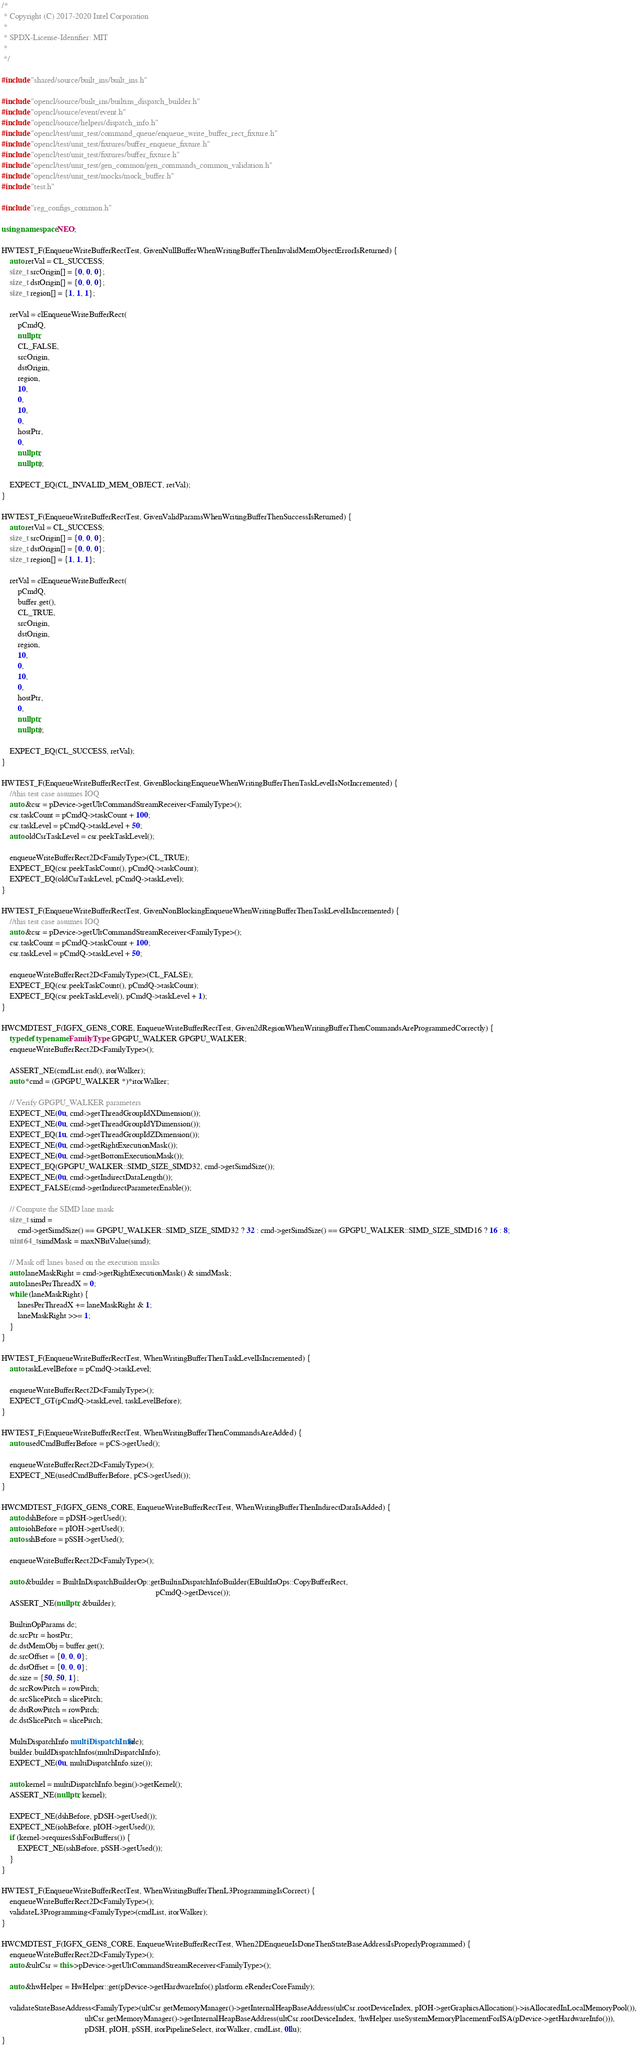Convert code to text. <code><loc_0><loc_0><loc_500><loc_500><_C++_>/*
 * Copyright (C) 2017-2020 Intel Corporation
 *
 * SPDX-License-Identifier: MIT
 *
 */

#include "shared/source/built_ins/built_ins.h"

#include "opencl/source/built_ins/builtins_dispatch_builder.h"
#include "opencl/source/event/event.h"
#include "opencl/source/helpers/dispatch_info.h"
#include "opencl/test/unit_test/command_queue/enqueue_write_buffer_rect_fixture.h"
#include "opencl/test/unit_test/fixtures/buffer_enqueue_fixture.h"
#include "opencl/test/unit_test/fixtures/buffer_fixture.h"
#include "opencl/test/unit_test/gen_common/gen_commands_common_validation.h"
#include "opencl/test/unit_test/mocks/mock_buffer.h"
#include "test.h"

#include "reg_configs_common.h"

using namespace NEO;

HWTEST_F(EnqueueWriteBufferRectTest, GivenNullBufferWhenWritingBufferThenInvalidMemObjectErrorIsReturned) {
    auto retVal = CL_SUCCESS;
    size_t srcOrigin[] = {0, 0, 0};
    size_t dstOrigin[] = {0, 0, 0};
    size_t region[] = {1, 1, 1};

    retVal = clEnqueueWriteBufferRect(
        pCmdQ,
        nullptr,
        CL_FALSE,
        srcOrigin,
        dstOrigin,
        region,
        10,
        0,
        10,
        0,
        hostPtr,
        0,
        nullptr,
        nullptr);

    EXPECT_EQ(CL_INVALID_MEM_OBJECT, retVal);
}

HWTEST_F(EnqueueWriteBufferRectTest, GivenValidParamsWhenWritingBufferThenSuccessIsReturned) {
    auto retVal = CL_SUCCESS;
    size_t srcOrigin[] = {0, 0, 0};
    size_t dstOrigin[] = {0, 0, 0};
    size_t region[] = {1, 1, 1};

    retVal = clEnqueueWriteBufferRect(
        pCmdQ,
        buffer.get(),
        CL_TRUE,
        srcOrigin,
        dstOrigin,
        region,
        10,
        0,
        10,
        0,
        hostPtr,
        0,
        nullptr,
        nullptr);

    EXPECT_EQ(CL_SUCCESS, retVal);
}

HWTEST_F(EnqueueWriteBufferRectTest, GivenBlockingEnqueueWhenWritingBufferThenTaskLevelIsNotIncremented) {
    //this test case assumes IOQ
    auto &csr = pDevice->getUltCommandStreamReceiver<FamilyType>();
    csr.taskCount = pCmdQ->taskCount + 100;
    csr.taskLevel = pCmdQ->taskLevel + 50;
    auto oldCsrTaskLevel = csr.peekTaskLevel();

    enqueueWriteBufferRect2D<FamilyType>(CL_TRUE);
    EXPECT_EQ(csr.peekTaskCount(), pCmdQ->taskCount);
    EXPECT_EQ(oldCsrTaskLevel, pCmdQ->taskLevel);
}

HWTEST_F(EnqueueWriteBufferRectTest, GivenNonBlockingEnqueueWhenWritingBufferThenTaskLevelIsIncremented) {
    //this test case assumes IOQ
    auto &csr = pDevice->getUltCommandStreamReceiver<FamilyType>();
    csr.taskCount = pCmdQ->taskCount + 100;
    csr.taskLevel = pCmdQ->taskLevel + 50;

    enqueueWriteBufferRect2D<FamilyType>(CL_FALSE);
    EXPECT_EQ(csr.peekTaskCount(), pCmdQ->taskCount);
    EXPECT_EQ(csr.peekTaskLevel(), pCmdQ->taskLevel + 1);
}

HWCMDTEST_F(IGFX_GEN8_CORE, EnqueueWriteBufferRectTest, Given2dRegionWhenWritingBufferThenCommandsAreProgrammedCorrectly) {
    typedef typename FamilyType::GPGPU_WALKER GPGPU_WALKER;
    enqueueWriteBufferRect2D<FamilyType>();

    ASSERT_NE(cmdList.end(), itorWalker);
    auto *cmd = (GPGPU_WALKER *)*itorWalker;

    // Verify GPGPU_WALKER parameters
    EXPECT_NE(0u, cmd->getThreadGroupIdXDimension());
    EXPECT_NE(0u, cmd->getThreadGroupIdYDimension());
    EXPECT_EQ(1u, cmd->getThreadGroupIdZDimension());
    EXPECT_NE(0u, cmd->getRightExecutionMask());
    EXPECT_NE(0u, cmd->getBottomExecutionMask());
    EXPECT_EQ(GPGPU_WALKER::SIMD_SIZE_SIMD32, cmd->getSimdSize());
    EXPECT_NE(0u, cmd->getIndirectDataLength());
    EXPECT_FALSE(cmd->getIndirectParameterEnable());

    // Compute the SIMD lane mask
    size_t simd =
        cmd->getSimdSize() == GPGPU_WALKER::SIMD_SIZE_SIMD32 ? 32 : cmd->getSimdSize() == GPGPU_WALKER::SIMD_SIZE_SIMD16 ? 16 : 8;
    uint64_t simdMask = maxNBitValue(simd);

    // Mask off lanes based on the execution masks
    auto laneMaskRight = cmd->getRightExecutionMask() & simdMask;
    auto lanesPerThreadX = 0;
    while (laneMaskRight) {
        lanesPerThreadX += laneMaskRight & 1;
        laneMaskRight >>= 1;
    }
}

HWTEST_F(EnqueueWriteBufferRectTest, WhenWritingBufferThenTaskLevelIsIncremented) {
    auto taskLevelBefore = pCmdQ->taskLevel;

    enqueueWriteBufferRect2D<FamilyType>();
    EXPECT_GT(pCmdQ->taskLevel, taskLevelBefore);
}

HWTEST_F(EnqueueWriteBufferRectTest, WhenWritingBufferThenCommandsAreAdded) {
    auto usedCmdBufferBefore = pCS->getUsed();

    enqueueWriteBufferRect2D<FamilyType>();
    EXPECT_NE(usedCmdBufferBefore, pCS->getUsed());
}

HWCMDTEST_F(IGFX_GEN8_CORE, EnqueueWriteBufferRectTest, WhenWritingBufferThenIndirectDataIsAdded) {
    auto dshBefore = pDSH->getUsed();
    auto iohBefore = pIOH->getUsed();
    auto sshBefore = pSSH->getUsed();

    enqueueWriteBufferRect2D<FamilyType>();

    auto &builder = BuiltInDispatchBuilderOp::getBuiltinDispatchInfoBuilder(EBuiltInOps::CopyBufferRect,
                                                                            pCmdQ->getDevice());
    ASSERT_NE(nullptr, &builder);

    BuiltinOpParams dc;
    dc.srcPtr = hostPtr;
    dc.dstMemObj = buffer.get();
    dc.srcOffset = {0, 0, 0};
    dc.dstOffset = {0, 0, 0};
    dc.size = {50, 50, 1};
    dc.srcRowPitch = rowPitch;
    dc.srcSlicePitch = slicePitch;
    dc.dstRowPitch = rowPitch;
    dc.dstSlicePitch = slicePitch;

    MultiDispatchInfo multiDispatchInfo(dc);
    builder.buildDispatchInfos(multiDispatchInfo);
    EXPECT_NE(0u, multiDispatchInfo.size());

    auto kernel = multiDispatchInfo.begin()->getKernel();
    ASSERT_NE(nullptr, kernel);

    EXPECT_NE(dshBefore, pDSH->getUsed());
    EXPECT_NE(iohBefore, pIOH->getUsed());
    if (kernel->requiresSshForBuffers()) {
        EXPECT_NE(sshBefore, pSSH->getUsed());
    }
}

HWTEST_F(EnqueueWriteBufferRectTest, WhenWritingBufferThenL3ProgrammingIsCorrect) {
    enqueueWriteBufferRect2D<FamilyType>();
    validateL3Programming<FamilyType>(cmdList, itorWalker);
}

HWCMDTEST_F(IGFX_GEN8_CORE, EnqueueWriteBufferRectTest, When2DEnqueueIsDoneThenStateBaseAddressIsProperlyProgrammed) {
    enqueueWriteBufferRect2D<FamilyType>();
    auto &ultCsr = this->pDevice->getUltCommandStreamReceiver<FamilyType>();

    auto &hwHelper = HwHelper::get(pDevice->getHardwareInfo().platform.eRenderCoreFamily);

    validateStateBaseAddress<FamilyType>(ultCsr.getMemoryManager()->getInternalHeapBaseAddress(ultCsr.rootDeviceIndex, pIOH->getGraphicsAllocation()->isAllocatedInLocalMemoryPool()),
                                         ultCsr.getMemoryManager()->getInternalHeapBaseAddress(ultCsr.rootDeviceIndex, !hwHelper.useSystemMemoryPlacementForISA(pDevice->getHardwareInfo())),
                                         pDSH, pIOH, pSSH, itorPipelineSelect, itorWalker, cmdList, 0llu);
}
</code> 